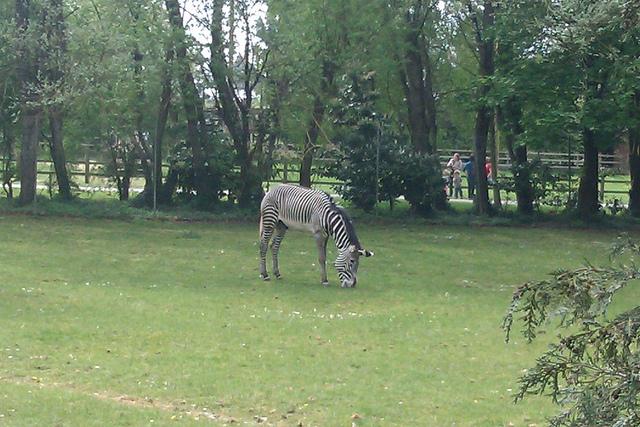What is the zebra doing?
Answer briefly. Eating. Can you see people in the picture?
Keep it brief. Yes. Is the animal in the photo domesticated?
Keep it brief. No. 